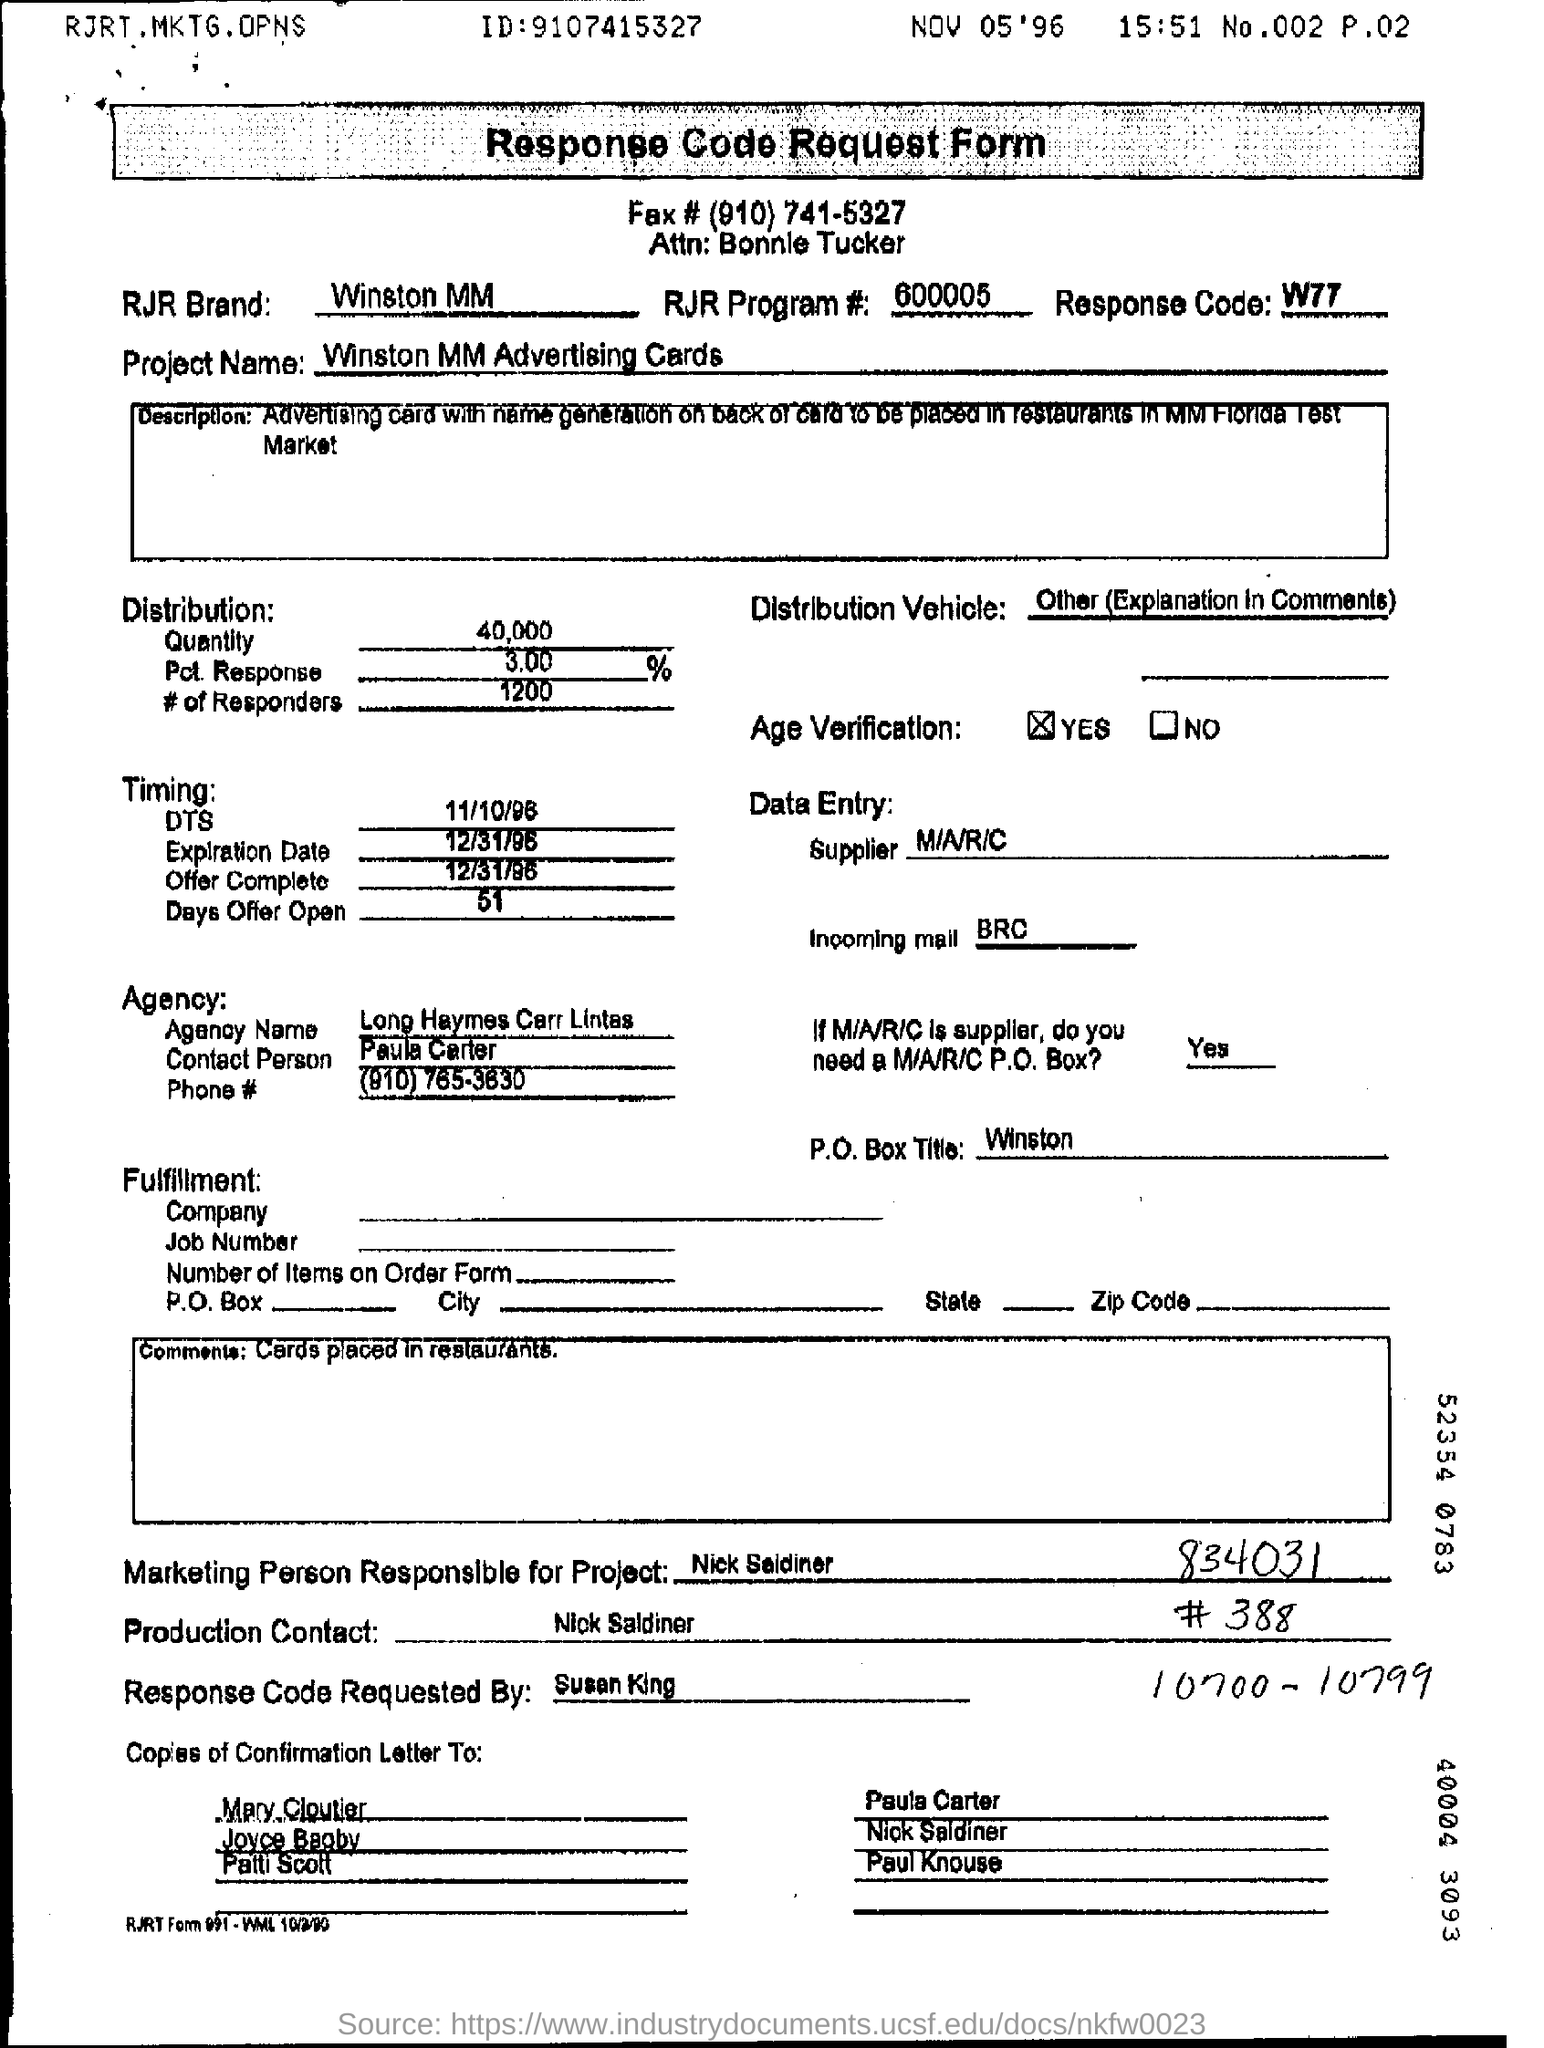What is the RJR  Brand?
Your answer should be very brief. Winston MM. What is the Response Code?
Your response must be concise. W77. How much is the Distribution Quantity?
Offer a terse response. 40,000. Who is the Data Entry Supplier?
Offer a terse response. M/A/R/C. What is the Agency Name?
Your response must be concise. Long Haymes Carr Lintas. 